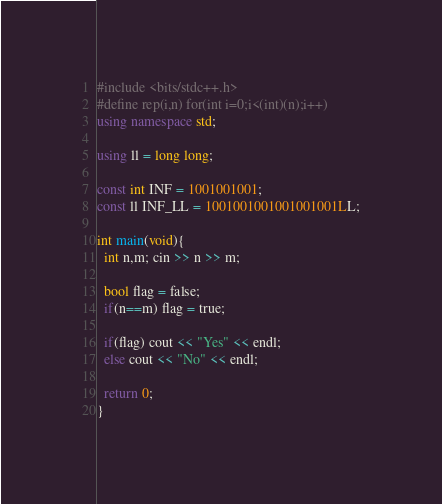Convert code to text. <code><loc_0><loc_0><loc_500><loc_500><_C++_>#include <bits/stdc++.h>
#define rep(i,n) for(int i=0;i<(int)(n);i++)
using namespace std;

using ll = long long;

const int INF = 1001001001;
const ll INF_LL = 1001001001001001001LL;

int main(void){
  int n,m; cin >> n >> m;

  bool flag = false;
  if(n==m) flag = true;

  if(flag) cout << "Yes" << endl;
  else cout << "No" << endl;
    
  return 0;
}
</code> 